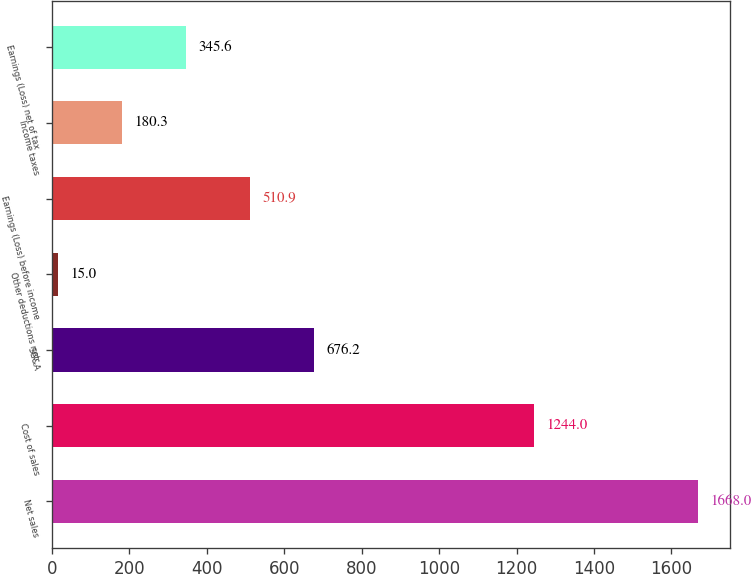<chart> <loc_0><loc_0><loc_500><loc_500><bar_chart><fcel>Net sales<fcel>Cost of sales<fcel>SG&A<fcel>Other deductions net<fcel>Earnings (Loss) before income<fcel>Income taxes<fcel>Earnings (Loss) net of tax<nl><fcel>1668<fcel>1244<fcel>676.2<fcel>15<fcel>510.9<fcel>180.3<fcel>345.6<nl></chart> 